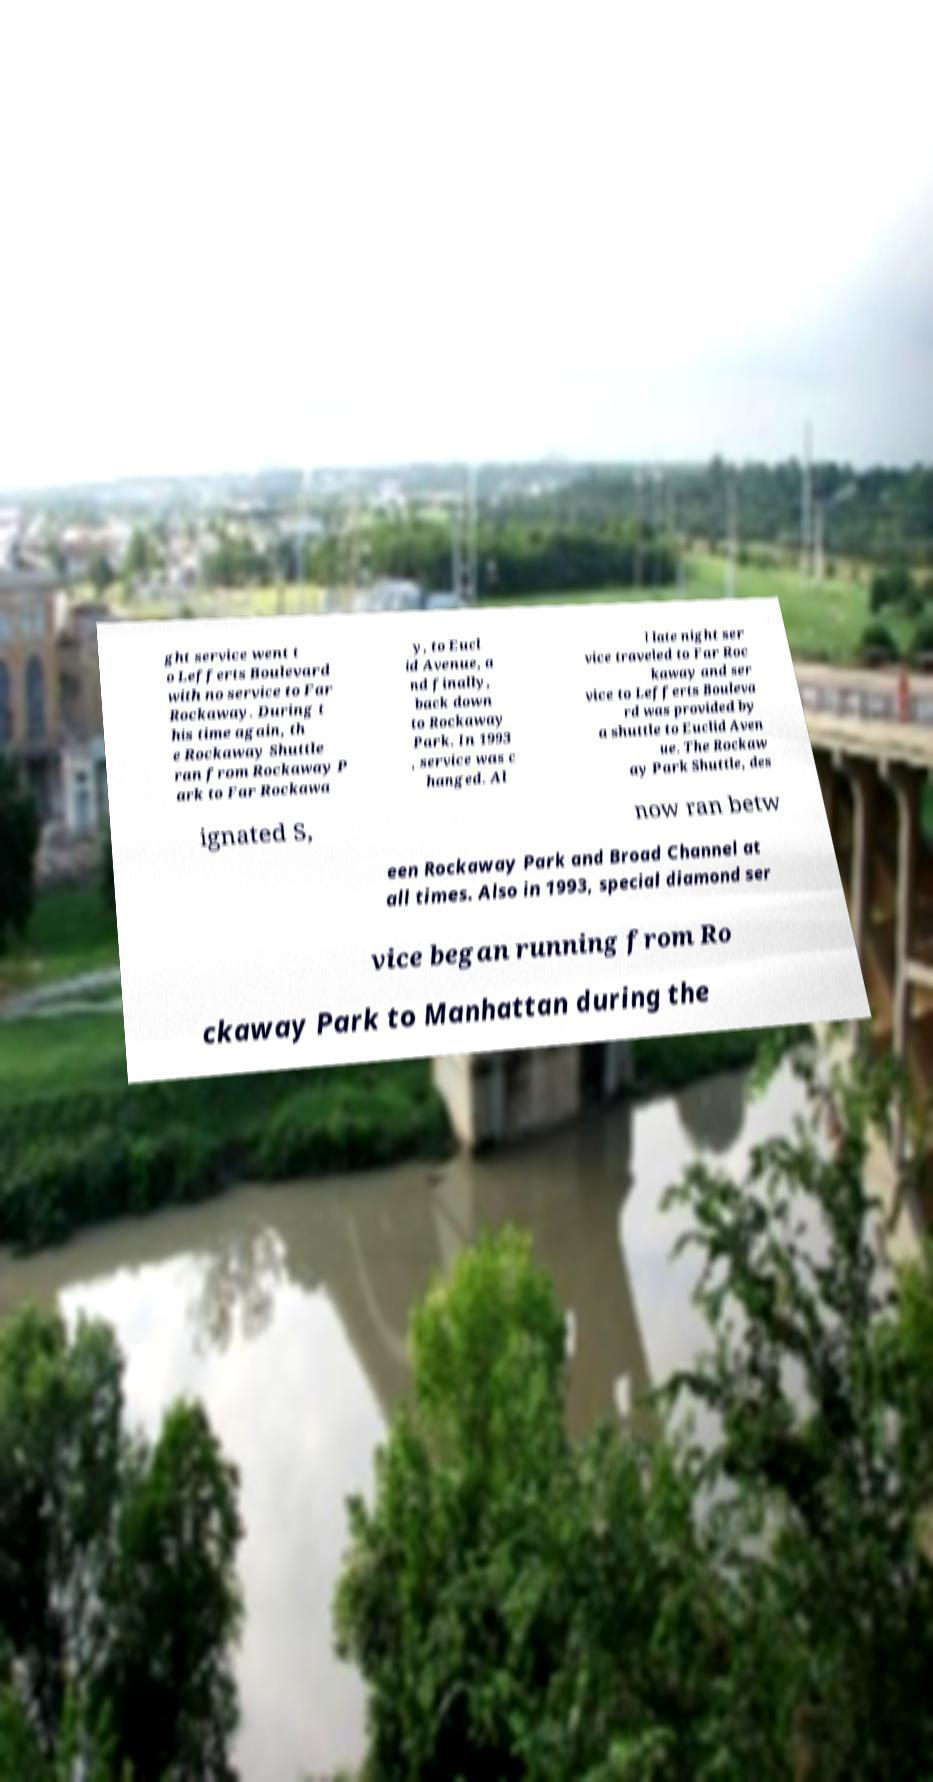There's text embedded in this image that I need extracted. Can you transcribe it verbatim? ght service went t o Lefferts Boulevard with no service to Far Rockaway. During t his time again, th e Rockaway Shuttle ran from Rockaway P ark to Far Rockawa y, to Eucl id Avenue, a nd finally, back down to Rockaway Park. In 1993 , service was c hanged. Al l late night ser vice traveled to Far Roc kaway and ser vice to Lefferts Bouleva rd was provided by a shuttle to Euclid Aven ue. The Rockaw ay Park Shuttle, des ignated S, now ran betw een Rockaway Park and Broad Channel at all times. Also in 1993, special diamond ser vice began running from Ro ckaway Park to Manhattan during the 